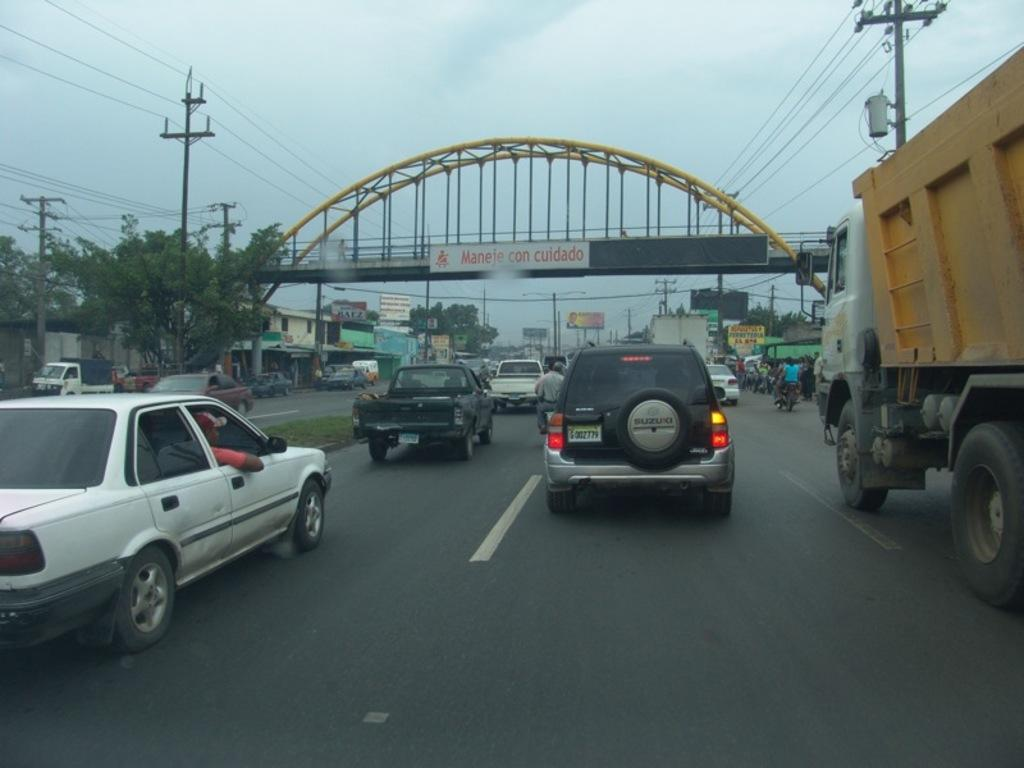What types of vehicles are present in the image? There are cars, trucks, and motorcycles in the image. What type of structure can be seen in the image? There is a bridge in the image. What else can be seen in the image besides vehicles and the bridge? There are current polls, buildings, banners, and trees in the image. What is visible at the top of the image? The sky is visible at the top of the image. Where is the bottle located in the image? There is no bottle present in the image. What type of insect can be seen on the banners in the image? There are no insects, including ladybugs, present in the image. 